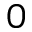Convert formula to latex. <formula><loc_0><loc_0><loc_500><loc_500>0</formula> 